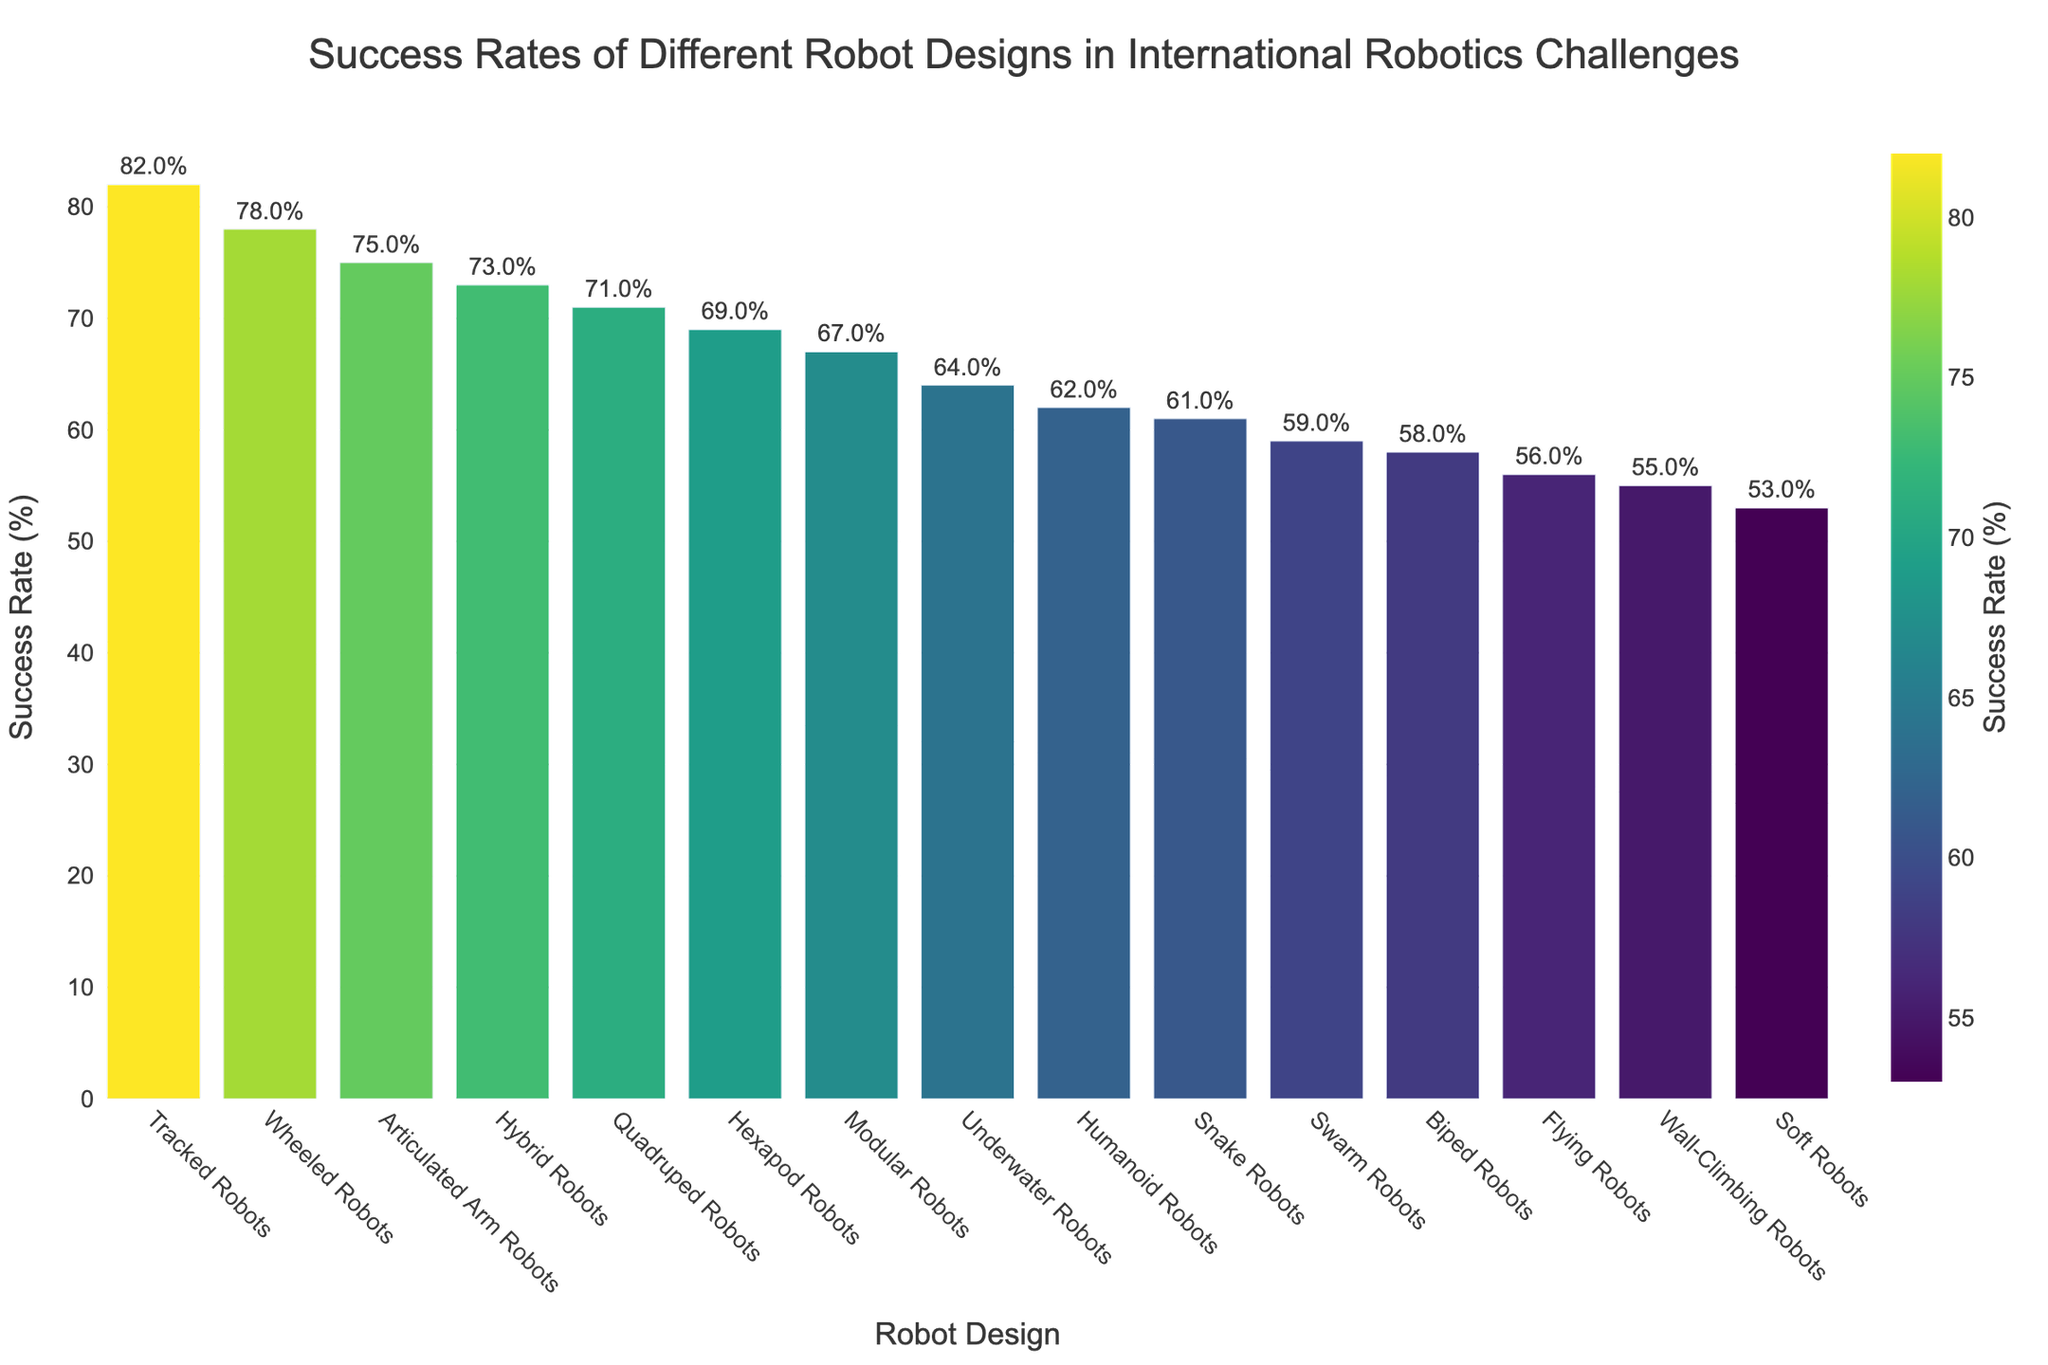What robot design has the highest success rate? The bar chart shows different robot designs along the x-axis and their corresponding success rates in percentage along the y-axis, sorted in descending order. The tallest bar represents the design with the highest success rate.
Answer: Tracked Robots Which robot design has the lowest success rate? The bar chart shows the different robot designs along the x-axis and their corresponding success rates in percentage along the y-axis, sorted in descending order. The shortest bar represents the design with the lowest success rate.
Answer: Soft Robots What is the difference in success rates between Tracked Robots and Flying Robots? First, identify the success rates for Tracked Robots and Flying Robots from the chart. Tracked Robots have a success rate of 82%, while Flying Robots have a success rate of 56%. Subtract the success rate of Flying Robots from that of Tracked Robots: 82% - 56% = 26%.
Answer: 26% Which has a higher success rate, Hexapod Robots or Articulated Arm Robots, and by how much? The bar chart shows that Hexapod Robots have a success rate of 69%, while Articulated Arm Robots have a 75% success rate. Subtract the success rate of Hexapod Robots from Articulated Arm Robots: 75% - 69% = 6%.
Answer: Articulated Arm Robots, 6% What is the combined success rate of Humanoid Robots, Quadruped Robots, and Snake Robots? Identify the success rates of each robot design from the chart: Humanoid Robots (62%), Quadruped Robots (71%), Snake Robots (61%). Add these success rates together: 62% + 71% + 61% = 194%.
Answer: 194% What is the average success rate of the top five robot designs? Identify the top five robot designs from the chart and their success rates: Tracked Robots (82%), Wheeled Robots (78%), Articulated Arm Robots (75%), Hybrid Robots (73%), Quadruped Robots (71%). Sum these success rates and divide by the number of designs: (82% + 78% + 75% + 73% + 71%) / 5 = 75.8%.
Answer: 75.8% How many robot designs have a success rate greater than 60%? Count the number of bars in the chart that have a success rate taller than the 60% mark. These designs are Wheeled Robots, Humanoid Robots, Quadruped Robots, Hexapod Robots, Tracked Robots, Underwater Robots, Modular Robots, Articulated Arm Robots, Snake Robots, Hybrid Robots. The count is 10 designs.
Answer: 10 What is the relative success rate of Wall-Climbing Robots compared to the median success rate in the dataset? First, list all success rates and find the median value. The sorted success rates are: 53%, 55%, 56%, 58%, 59%, 61%, 62%, 64%, 67%, 69%, 71%, 73%, 75%, 78%, 82%. The median is the 8th value, which is 64%. The success rate for Wall-Climbing Robots is 55%. The relative success rate is found by subtracting the success rate of Wall-Climbing Robots from the median: 64% - 55% = 9%.
Answer: 9% 